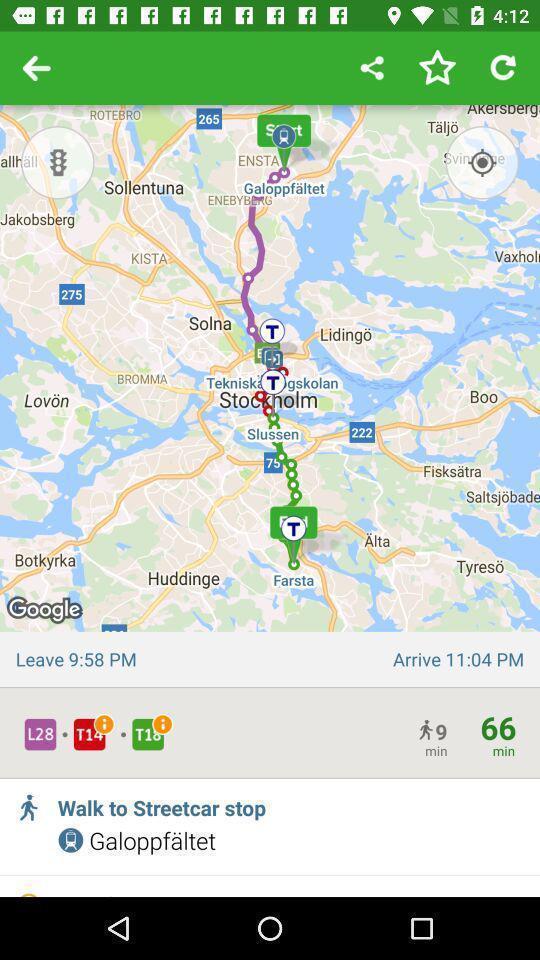Describe this image in words. Screen showing a location on map. 